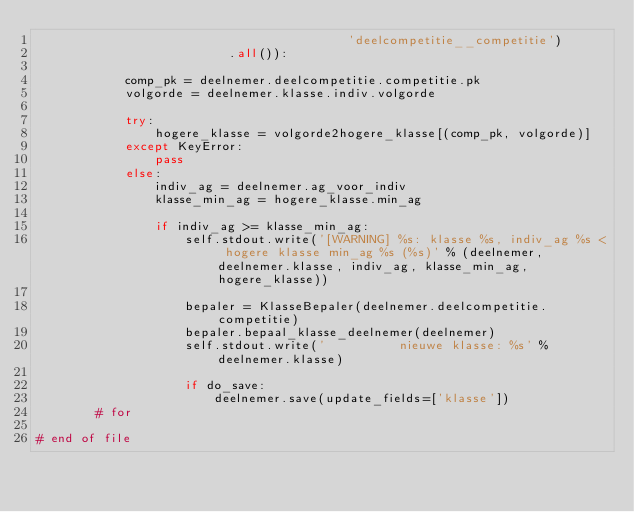Convert code to text. <code><loc_0><loc_0><loc_500><loc_500><_Python_>                                          'deelcompetitie__competitie')
                          .all()):

            comp_pk = deelnemer.deelcompetitie.competitie.pk
            volgorde = deelnemer.klasse.indiv.volgorde

            try:
                hogere_klasse = volgorde2hogere_klasse[(comp_pk, volgorde)]
            except KeyError:
                pass
            else:
                indiv_ag = deelnemer.ag_voor_indiv
                klasse_min_ag = hogere_klasse.min_ag

                if indiv_ag >= klasse_min_ag:
                    self.stdout.write('[WARNING] %s: klasse %s, indiv_ag %s < hogere klasse min_ag %s (%s)' % (deelnemer, deelnemer.klasse, indiv_ag, klasse_min_ag, hogere_klasse))

                    bepaler = KlasseBepaler(deelnemer.deelcompetitie.competitie)
                    bepaler.bepaal_klasse_deelnemer(deelnemer)
                    self.stdout.write('          nieuwe klasse: %s' % deelnemer.klasse)

                    if do_save:
                        deelnemer.save(update_fields=['klasse'])
        # for

# end of file
</code> 